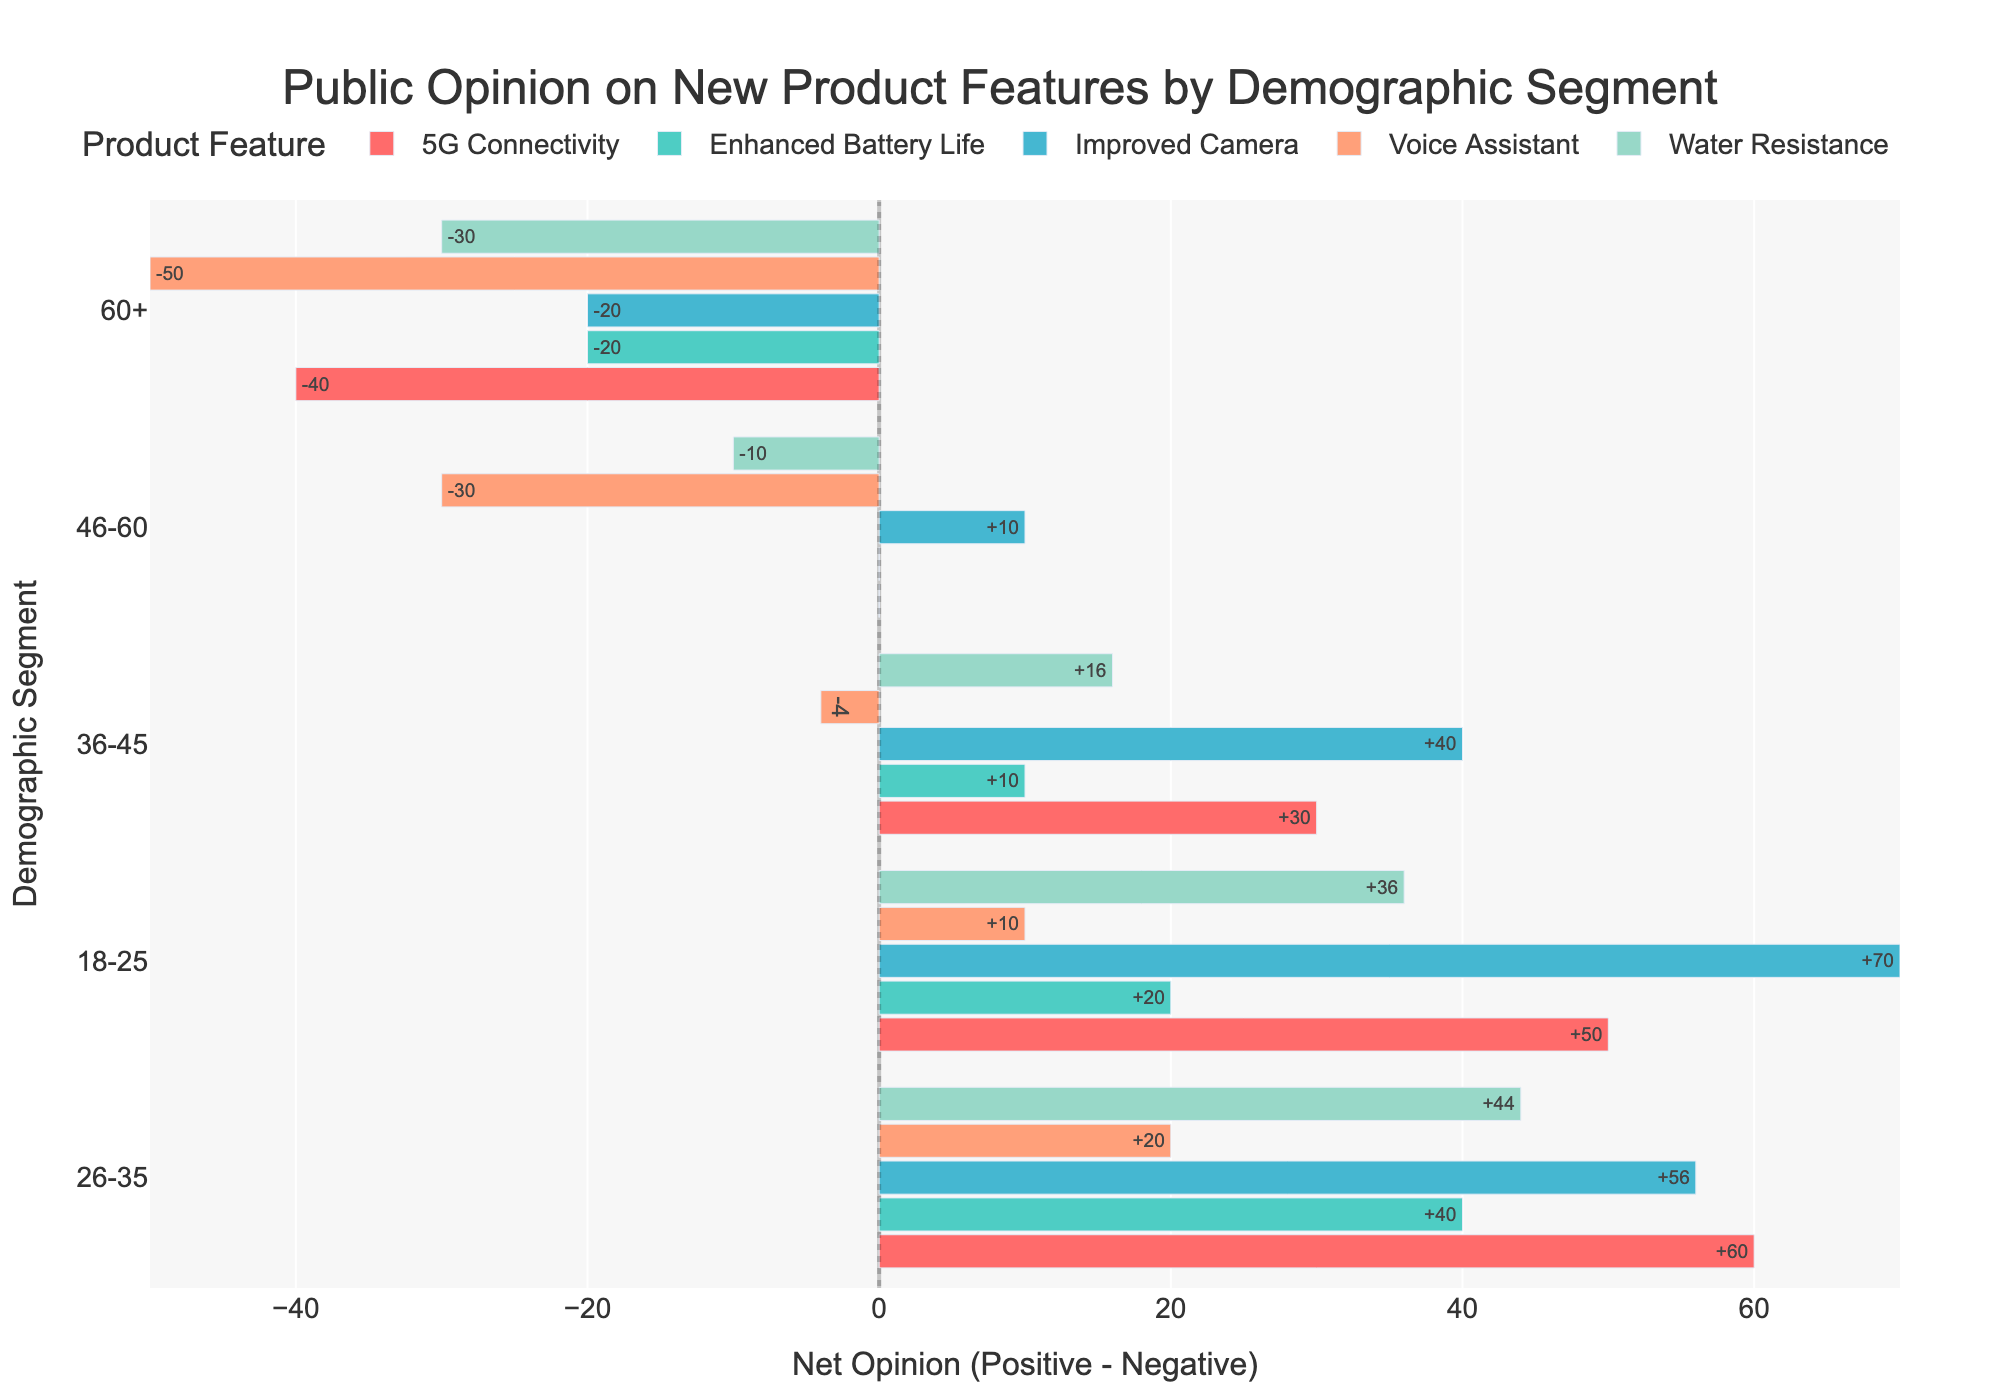How does the net opinion of Enhanced Battery Life differ between the 18-25 and 60+ demographic segments? The net opinion for Enhanced Battery Life in the 18-25 demographic segment is 60 - 40 = +20. For the 60+ demographic segment, it's 40 - 60 = -20. The difference is +20 - (-20) = +40.
Answer: +40 Which product feature has the highest positive opinion among the 18-25 demographic segment, and what is the net opinion for that feature? The product feature with the highest positive opinion among the 18-25 demographic segment is the Improved Camera, with a positive opinion of 85. The net opinion is 85 - 15 = +70.
Answer: Improved Camera, +70 Compare the net opinions for 5G Connectivity and Voice Assistant in the 46-60 demographic segment. The net opinion for 5G Connectivity in the 46-60 demographic segment is 50 - 50 = 0. The net opinion for Voice Assistant in the same segment is 35 - 65 = -30.
Answer: 5G Connectivity: 0, Voice Assistant: -30 What is the average net opinion for Water Resistance across all demographic segments? The net opinions for Water Resistance are +36, +44, +16, -10, and -30 for the 18-25, 26-35, 36-45, 46-60, and 60+ segments respectively. The average net opinion is (36 + 44 + 16 - 10 - 30) / 5 = 11.2.
Answer: 11.2 Identify the demographic segment with the most negative net opinion for Voice Assistant. The most negative net opinion for Voice Assistant is found in the 60+ demographic segment with a net opinion of 25 - 75 = -50.
Answer: 60+ Between Enhanced Battery Life and Improved Camera, which product feature do the 36-45 demographic segment prefer and by what net opinion difference? The 36-45 demographic segment has a net opinion of +10 for Enhanced Battery Life (55 - 45) and +40 for Improved Camera (70 - 30). The difference is +40 - +10 = +30.
Answer: Improved Camera, +30 Which demographic segment shows the highest variance in net opinions across all product features? Calculate the net opinions for all product features across each demographic segment and find the demographic segment with the highest variance. The highest difference between the most positive and the most negative net opinions for the 18-25 segment is (70 - (-50)) = 120.
Answer: 18-25 What is the product feature with the smallest range of net opinions across demographic segments? The ranges of net opinions for each product feature are calculated as follows: Enhanced Battery Life (40), 5G Connectivity (70), Water Resistance (66), Improved Camera (70), and Voice Assistant (80). The smallest range is for Enhanced Battery Life with a range of 40.
Answer: Enhanced Battery Life 